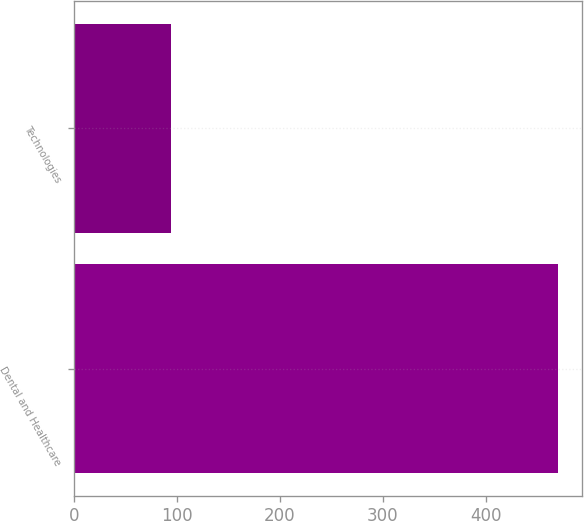Convert chart to OTSL. <chart><loc_0><loc_0><loc_500><loc_500><bar_chart><fcel>Dental and Healthcare<fcel>Technologies<nl><fcel>470.1<fcel>93.7<nl></chart> 